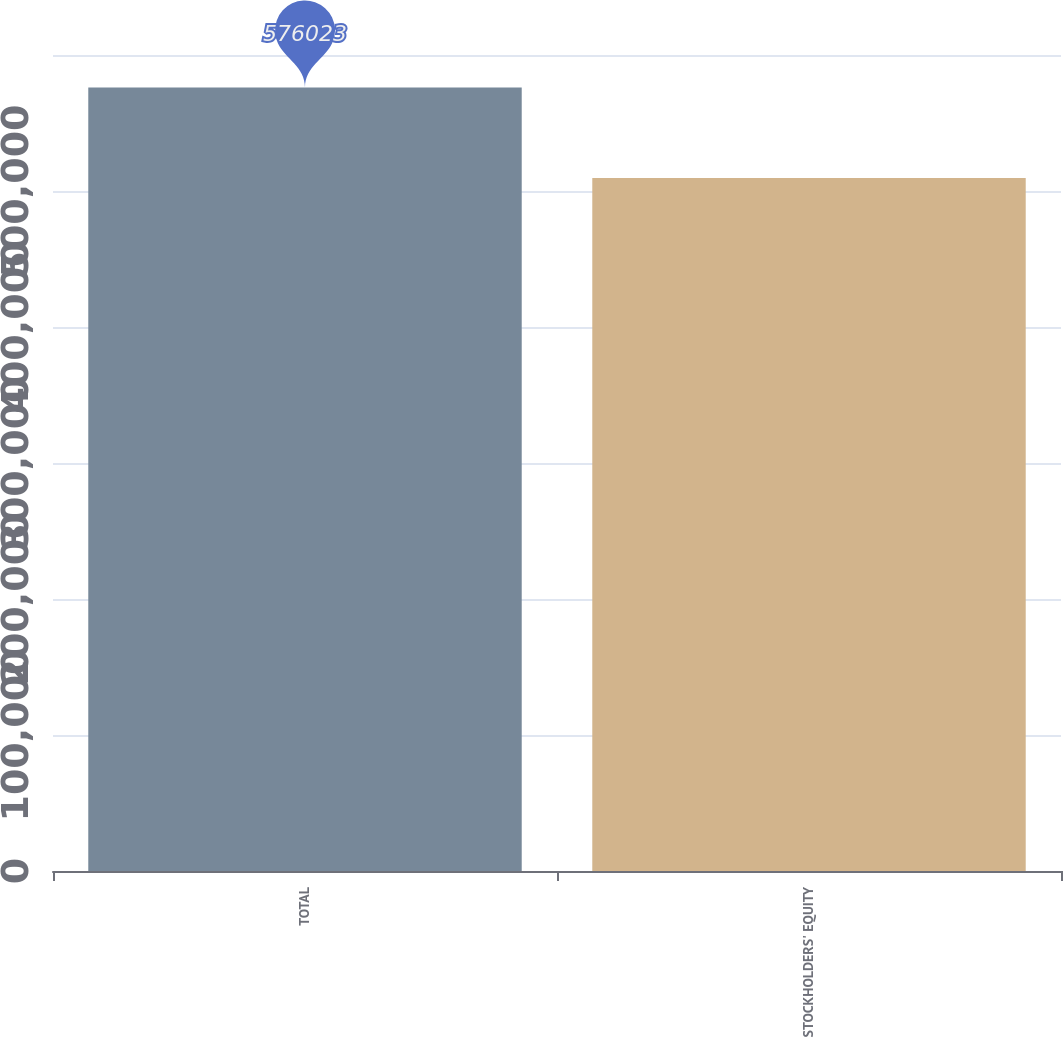Convert chart. <chart><loc_0><loc_0><loc_500><loc_500><bar_chart><fcel>TOTAL<fcel>STOCKHOLDERS' EQUITY<nl><fcel>576023<fcel>509516<nl></chart> 